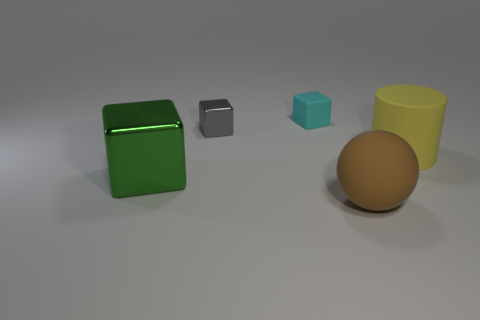Add 3 green things. How many objects exist? 8 Subtract all cylinders. How many objects are left? 4 Subtract 0 brown blocks. How many objects are left? 5 Subtract all tiny purple rubber cylinders. Subtract all large brown things. How many objects are left? 4 Add 5 cyan things. How many cyan things are left? 6 Add 2 large yellow things. How many large yellow things exist? 3 